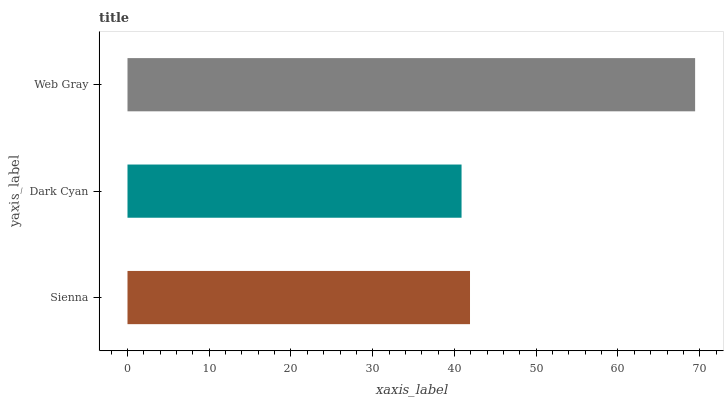Is Dark Cyan the minimum?
Answer yes or no. Yes. Is Web Gray the maximum?
Answer yes or no. Yes. Is Web Gray the minimum?
Answer yes or no. No. Is Dark Cyan the maximum?
Answer yes or no. No. Is Web Gray greater than Dark Cyan?
Answer yes or no. Yes. Is Dark Cyan less than Web Gray?
Answer yes or no. Yes. Is Dark Cyan greater than Web Gray?
Answer yes or no. No. Is Web Gray less than Dark Cyan?
Answer yes or no. No. Is Sienna the high median?
Answer yes or no. Yes. Is Sienna the low median?
Answer yes or no. Yes. Is Dark Cyan the high median?
Answer yes or no. No. Is Web Gray the low median?
Answer yes or no. No. 